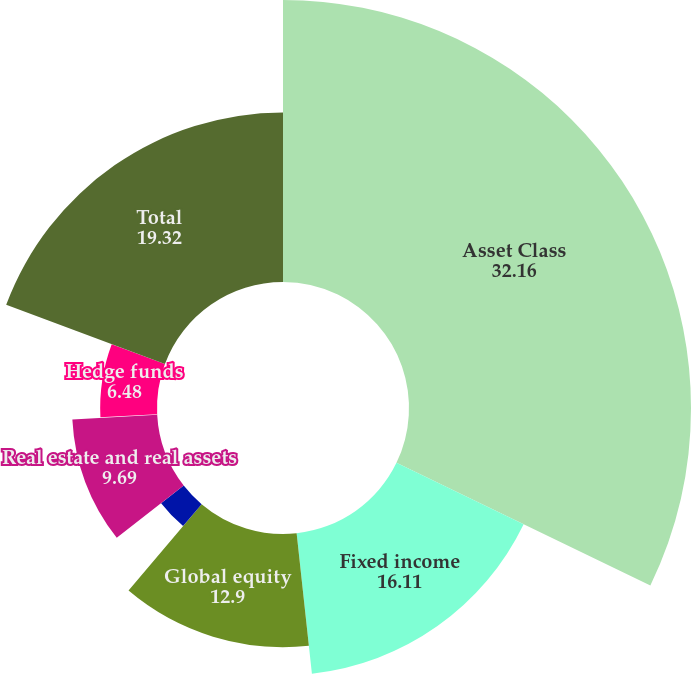Convert chart to OTSL. <chart><loc_0><loc_0><loc_500><loc_500><pie_chart><fcel>Asset Class<fcel>Fixed income<fcel>Global equity<fcel>Private equity<fcel>Real estate and real assets<fcel>Global strategies<fcel>Hedge funds<fcel>Total<nl><fcel>32.16%<fcel>16.11%<fcel>12.9%<fcel>3.27%<fcel>9.69%<fcel>0.06%<fcel>6.48%<fcel>19.32%<nl></chart> 